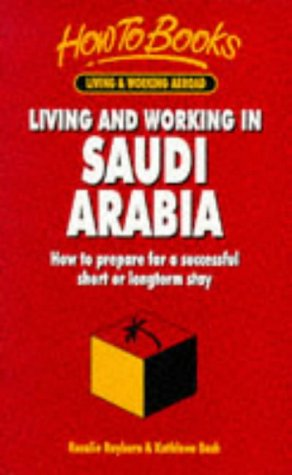Who is the author of this book?
Answer the question using a single word or phrase. Rosalie Rayburn What is the title of this book? Living & Working in Saudi Arabia: How to Prepare for a Successful Short or Longterm Stay (Living & Working Abroad) What is the genre of this book? Travel Is this a journey related book? Yes Is this a child-care book? No 